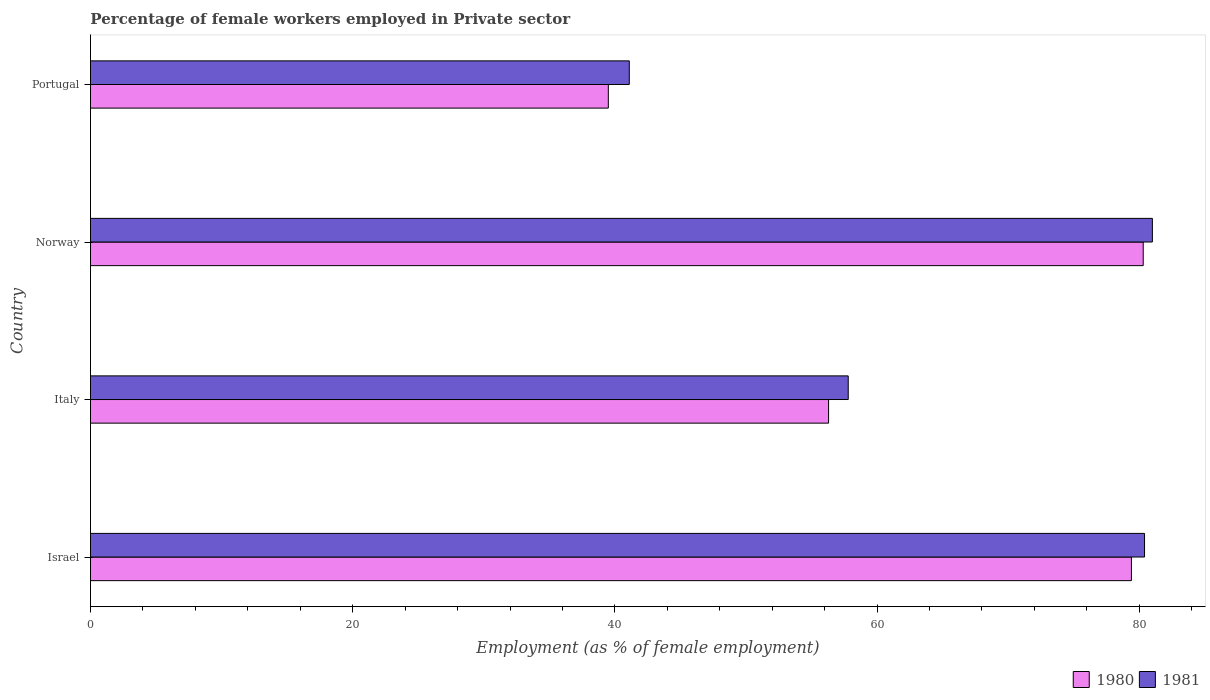How many groups of bars are there?
Your answer should be compact. 4. How many bars are there on the 4th tick from the bottom?
Make the answer very short. 2. In how many cases, is the number of bars for a given country not equal to the number of legend labels?
Offer a terse response. 0. What is the percentage of females employed in Private sector in 1981 in Norway?
Provide a short and direct response. 81. Across all countries, what is the maximum percentage of females employed in Private sector in 1980?
Your answer should be compact. 80.3. Across all countries, what is the minimum percentage of females employed in Private sector in 1981?
Provide a succinct answer. 41.1. What is the total percentage of females employed in Private sector in 1980 in the graph?
Make the answer very short. 255.5. What is the difference between the percentage of females employed in Private sector in 1980 in Italy and that in Norway?
Your response must be concise. -24. What is the difference between the percentage of females employed in Private sector in 1980 in Italy and the percentage of females employed in Private sector in 1981 in Israel?
Offer a terse response. -24.1. What is the average percentage of females employed in Private sector in 1981 per country?
Your answer should be compact. 65.07. What is the difference between the percentage of females employed in Private sector in 1980 and percentage of females employed in Private sector in 1981 in Portugal?
Your response must be concise. -1.6. What is the ratio of the percentage of females employed in Private sector in 1980 in Italy to that in Norway?
Offer a terse response. 0.7. What is the difference between the highest and the second highest percentage of females employed in Private sector in 1980?
Give a very brief answer. 0.9. What is the difference between the highest and the lowest percentage of females employed in Private sector in 1980?
Ensure brevity in your answer.  40.8. In how many countries, is the percentage of females employed in Private sector in 1981 greater than the average percentage of females employed in Private sector in 1981 taken over all countries?
Offer a very short reply. 2. How many bars are there?
Your answer should be compact. 8. Are all the bars in the graph horizontal?
Offer a terse response. Yes. How many countries are there in the graph?
Offer a terse response. 4. What is the difference between two consecutive major ticks on the X-axis?
Ensure brevity in your answer.  20. Does the graph contain any zero values?
Provide a short and direct response. No. Does the graph contain grids?
Give a very brief answer. No. How many legend labels are there?
Your answer should be compact. 2. What is the title of the graph?
Provide a short and direct response. Percentage of female workers employed in Private sector. Does "1982" appear as one of the legend labels in the graph?
Give a very brief answer. No. What is the label or title of the X-axis?
Keep it short and to the point. Employment (as % of female employment). What is the label or title of the Y-axis?
Your answer should be compact. Country. What is the Employment (as % of female employment) in 1980 in Israel?
Ensure brevity in your answer.  79.4. What is the Employment (as % of female employment) of 1981 in Israel?
Provide a short and direct response. 80.4. What is the Employment (as % of female employment) of 1980 in Italy?
Provide a short and direct response. 56.3. What is the Employment (as % of female employment) in 1981 in Italy?
Make the answer very short. 57.8. What is the Employment (as % of female employment) in 1980 in Norway?
Your answer should be very brief. 80.3. What is the Employment (as % of female employment) of 1980 in Portugal?
Your response must be concise. 39.5. What is the Employment (as % of female employment) in 1981 in Portugal?
Make the answer very short. 41.1. Across all countries, what is the maximum Employment (as % of female employment) in 1980?
Offer a very short reply. 80.3. Across all countries, what is the maximum Employment (as % of female employment) of 1981?
Make the answer very short. 81. Across all countries, what is the minimum Employment (as % of female employment) in 1980?
Ensure brevity in your answer.  39.5. Across all countries, what is the minimum Employment (as % of female employment) in 1981?
Give a very brief answer. 41.1. What is the total Employment (as % of female employment) of 1980 in the graph?
Provide a short and direct response. 255.5. What is the total Employment (as % of female employment) of 1981 in the graph?
Provide a short and direct response. 260.3. What is the difference between the Employment (as % of female employment) of 1980 in Israel and that in Italy?
Offer a terse response. 23.1. What is the difference between the Employment (as % of female employment) in 1981 in Israel and that in Italy?
Give a very brief answer. 22.6. What is the difference between the Employment (as % of female employment) of 1980 in Israel and that in Norway?
Your answer should be compact. -0.9. What is the difference between the Employment (as % of female employment) of 1981 in Israel and that in Norway?
Your answer should be very brief. -0.6. What is the difference between the Employment (as % of female employment) in 1980 in Israel and that in Portugal?
Keep it short and to the point. 39.9. What is the difference between the Employment (as % of female employment) of 1981 in Israel and that in Portugal?
Your answer should be compact. 39.3. What is the difference between the Employment (as % of female employment) in 1981 in Italy and that in Norway?
Ensure brevity in your answer.  -23.2. What is the difference between the Employment (as % of female employment) of 1980 in Italy and that in Portugal?
Provide a short and direct response. 16.8. What is the difference between the Employment (as % of female employment) in 1980 in Norway and that in Portugal?
Offer a terse response. 40.8. What is the difference between the Employment (as % of female employment) of 1981 in Norway and that in Portugal?
Your response must be concise. 39.9. What is the difference between the Employment (as % of female employment) in 1980 in Israel and the Employment (as % of female employment) in 1981 in Italy?
Provide a short and direct response. 21.6. What is the difference between the Employment (as % of female employment) of 1980 in Israel and the Employment (as % of female employment) of 1981 in Portugal?
Provide a short and direct response. 38.3. What is the difference between the Employment (as % of female employment) in 1980 in Italy and the Employment (as % of female employment) in 1981 in Norway?
Provide a short and direct response. -24.7. What is the difference between the Employment (as % of female employment) in 1980 in Italy and the Employment (as % of female employment) in 1981 in Portugal?
Your answer should be very brief. 15.2. What is the difference between the Employment (as % of female employment) in 1980 in Norway and the Employment (as % of female employment) in 1981 in Portugal?
Ensure brevity in your answer.  39.2. What is the average Employment (as % of female employment) of 1980 per country?
Make the answer very short. 63.88. What is the average Employment (as % of female employment) in 1981 per country?
Offer a terse response. 65.08. What is the difference between the Employment (as % of female employment) in 1980 and Employment (as % of female employment) in 1981 in Norway?
Your response must be concise. -0.7. What is the difference between the Employment (as % of female employment) in 1980 and Employment (as % of female employment) in 1981 in Portugal?
Provide a short and direct response. -1.6. What is the ratio of the Employment (as % of female employment) of 1980 in Israel to that in Italy?
Offer a very short reply. 1.41. What is the ratio of the Employment (as % of female employment) in 1981 in Israel to that in Italy?
Your answer should be compact. 1.39. What is the ratio of the Employment (as % of female employment) of 1980 in Israel to that in Norway?
Make the answer very short. 0.99. What is the ratio of the Employment (as % of female employment) in 1980 in Israel to that in Portugal?
Provide a short and direct response. 2.01. What is the ratio of the Employment (as % of female employment) in 1981 in Israel to that in Portugal?
Your answer should be compact. 1.96. What is the ratio of the Employment (as % of female employment) of 1980 in Italy to that in Norway?
Offer a terse response. 0.7. What is the ratio of the Employment (as % of female employment) in 1981 in Italy to that in Norway?
Give a very brief answer. 0.71. What is the ratio of the Employment (as % of female employment) in 1980 in Italy to that in Portugal?
Provide a short and direct response. 1.43. What is the ratio of the Employment (as % of female employment) in 1981 in Italy to that in Portugal?
Keep it short and to the point. 1.41. What is the ratio of the Employment (as % of female employment) of 1980 in Norway to that in Portugal?
Your response must be concise. 2.03. What is the ratio of the Employment (as % of female employment) of 1981 in Norway to that in Portugal?
Give a very brief answer. 1.97. What is the difference between the highest and the second highest Employment (as % of female employment) in 1981?
Provide a short and direct response. 0.6. What is the difference between the highest and the lowest Employment (as % of female employment) in 1980?
Your answer should be compact. 40.8. What is the difference between the highest and the lowest Employment (as % of female employment) of 1981?
Your answer should be very brief. 39.9. 